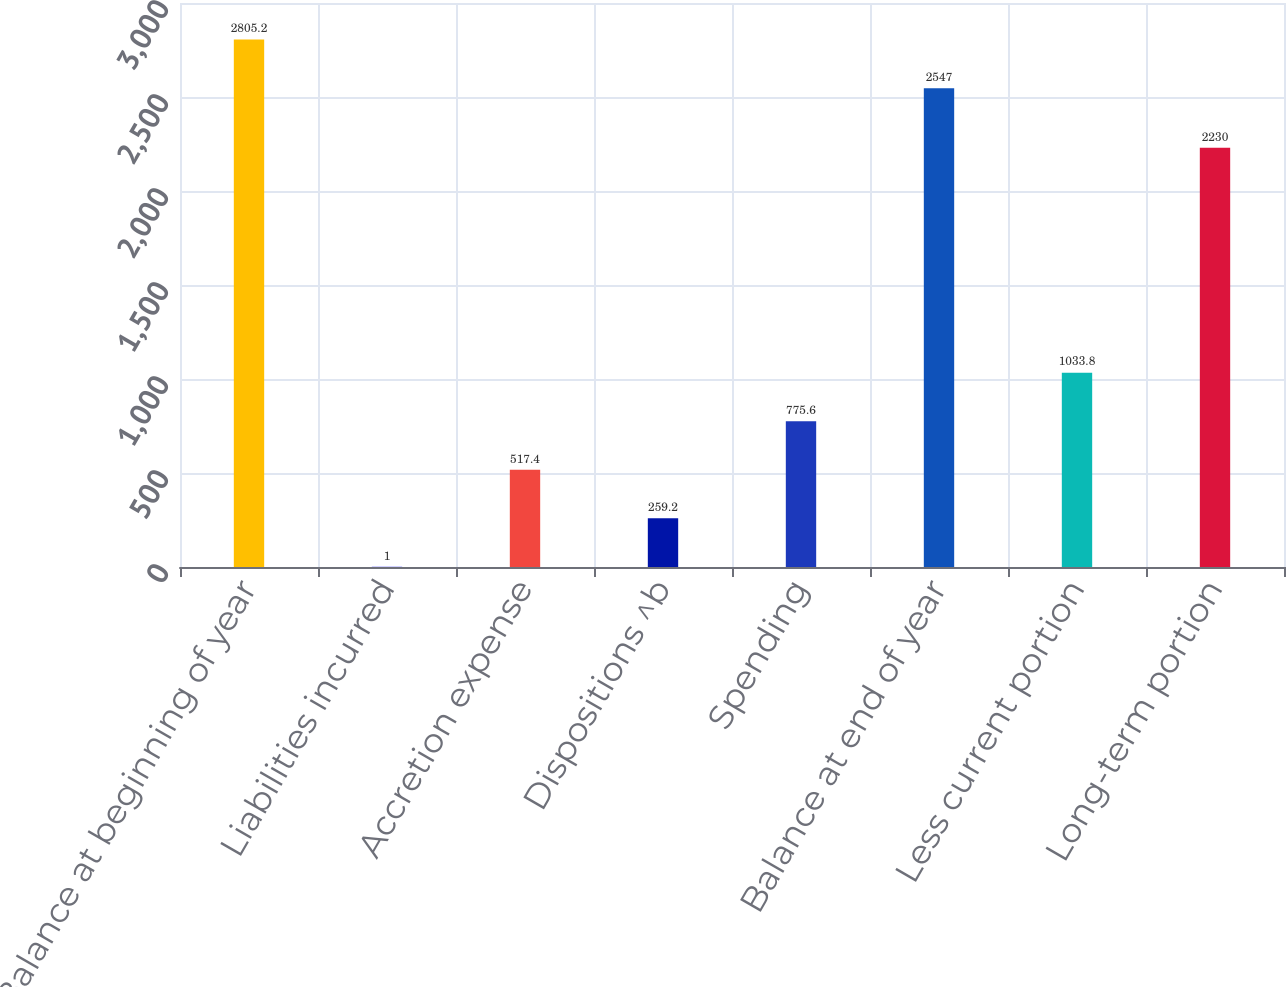Convert chart to OTSL. <chart><loc_0><loc_0><loc_500><loc_500><bar_chart><fcel>Balance at beginning of year<fcel>Liabilities incurred<fcel>Accretion expense<fcel>Dispositions ^b<fcel>Spending<fcel>Balance at end of year<fcel>Less current portion<fcel>Long-term portion<nl><fcel>2805.2<fcel>1<fcel>517.4<fcel>259.2<fcel>775.6<fcel>2547<fcel>1033.8<fcel>2230<nl></chart> 